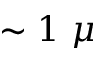Convert formula to latex. <formula><loc_0><loc_0><loc_500><loc_500>\sim 1 \mu</formula> 